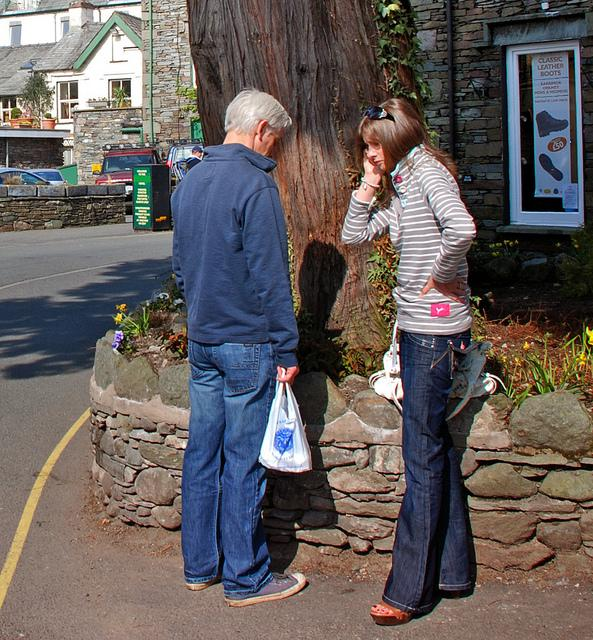What does the woman have in her right hand? Please explain your reasoning. phone. The woman has a phone. 